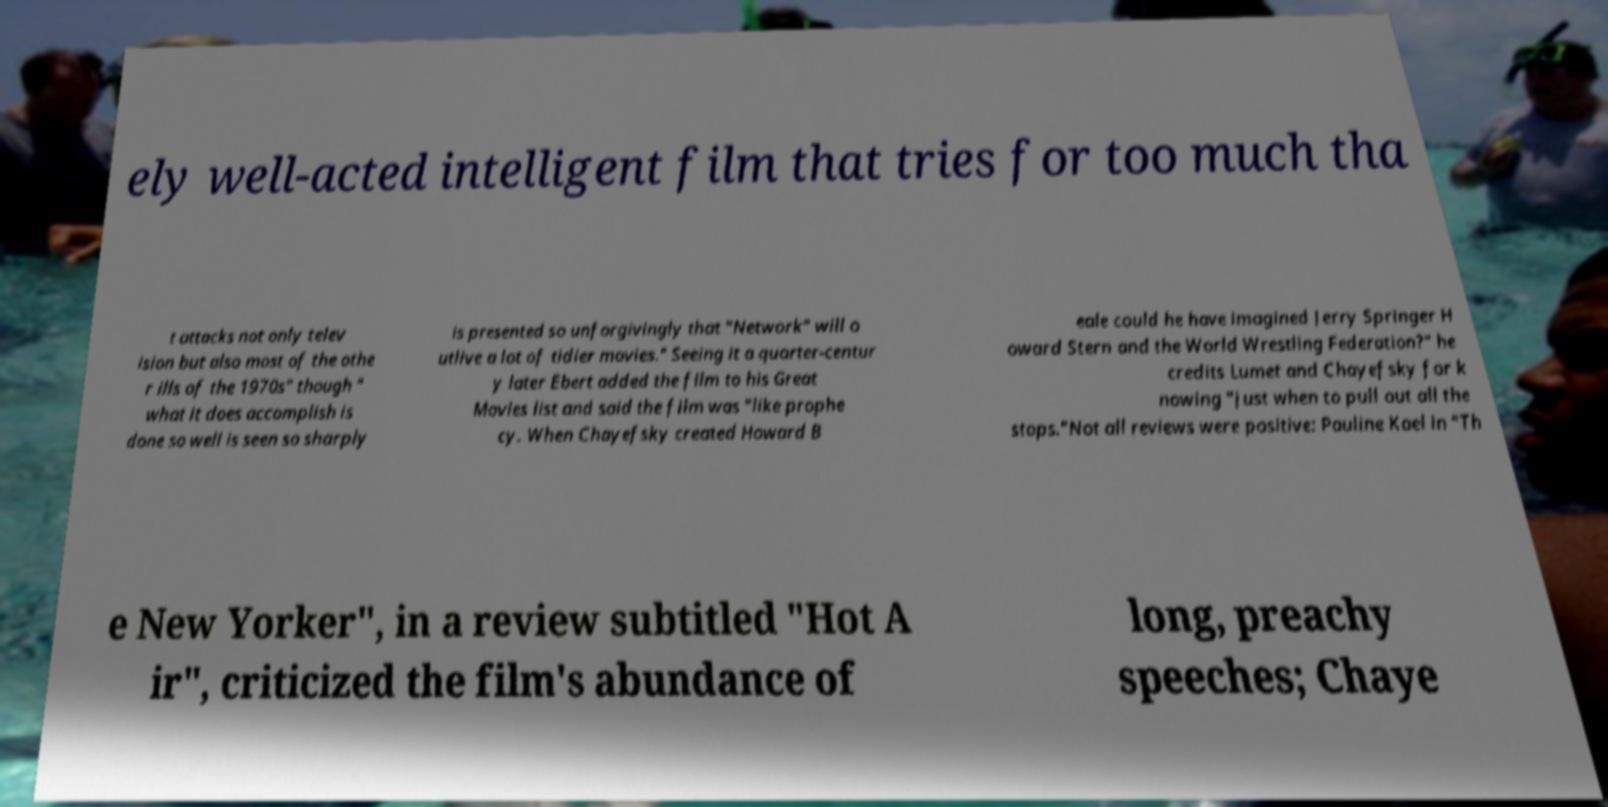Can you accurately transcribe the text from the provided image for me? ely well-acted intelligent film that tries for too much tha t attacks not only telev ision but also most of the othe r ills of the 1970s" though " what it does accomplish is done so well is seen so sharply is presented so unforgivingly that "Network" will o utlive a lot of tidier movies." Seeing it a quarter-centur y later Ebert added the film to his Great Movies list and said the film was "like prophe cy. When Chayefsky created Howard B eale could he have imagined Jerry Springer H oward Stern and the World Wrestling Federation?" he credits Lumet and Chayefsky for k nowing "just when to pull out all the stops."Not all reviews were positive: Pauline Kael in "Th e New Yorker", in a review subtitled "Hot A ir", criticized the film's abundance of long, preachy speeches; Chaye 